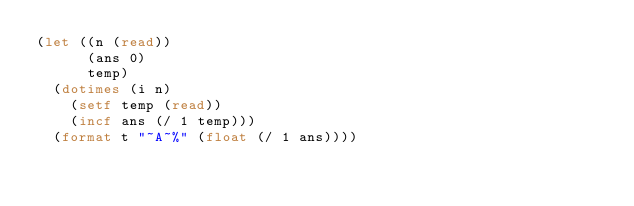<code> <loc_0><loc_0><loc_500><loc_500><_Lisp_>(let ((n (read))
      (ans 0)
      temp)
  (dotimes (i n)
    (setf temp (read))
    (incf ans (/ 1 temp)))
  (format t "~A~%" (float (/ 1 ans))))
</code> 